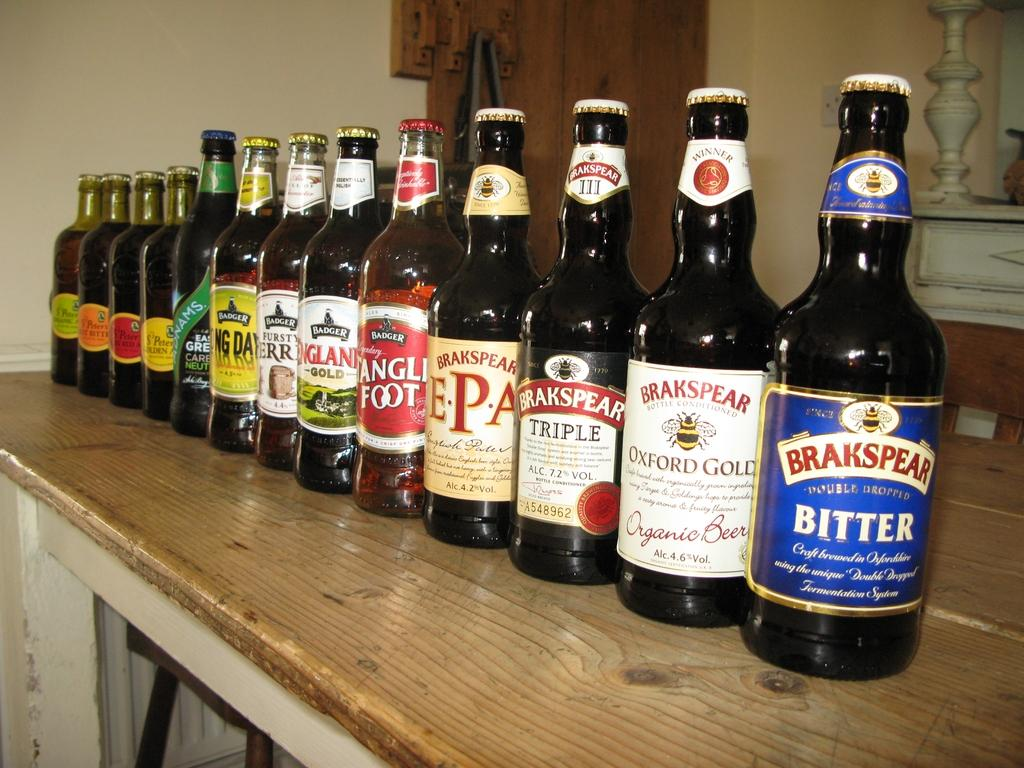<image>
Offer a succinct explanation of the picture presented. An assortment of beer bottles are lined up on a shelf, the first of which is Brakspear Bitter. 